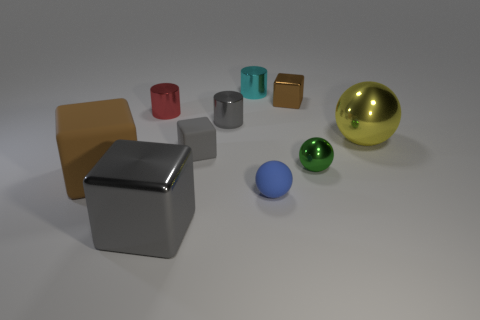The ball that is the same size as the green shiny object is what color?
Ensure brevity in your answer.  Blue. There is a brown cube behind the gray rubber thing; how many tiny red cylinders are left of it?
Offer a terse response. 1. How many big things are on the right side of the red metallic cylinder and in front of the yellow shiny sphere?
Provide a short and direct response. 1. What number of objects are either small cylinders left of the big gray shiny cube or large metal spheres that are on the right side of the small gray shiny cylinder?
Make the answer very short. 2. What number of other things are the same size as the blue matte ball?
Your answer should be compact. 6. What is the shape of the tiny gray thing that is in front of the large metal object on the right side of the small brown metallic cube?
Provide a short and direct response. Cube. There is a big metal object in front of the brown rubber block; does it have the same color as the small matte thing behind the tiny metallic sphere?
Your answer should be very brief. Yes. Is there any other thing that is the same color as the small metallic ball?
Provide a succinct answer. No. What color is the tiny metallic ball?
Keep it short and to the point. Green. Are any big purple metal cubes visible?
Your answer should be compact. No. 